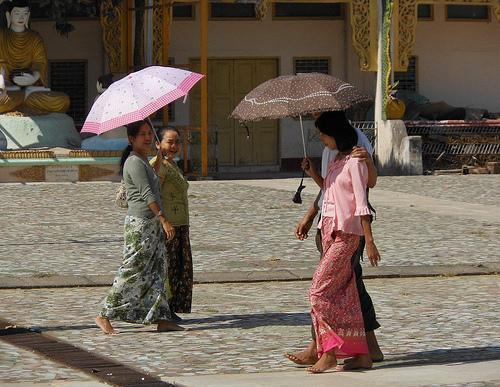How many umbrellas are here?
Give a very brief answer. 2. How many people are in this picture?
Give a very brief answer. 4. How many umbrellas are visible in this photo?
Give a very brief answer. 2. 